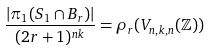<formula> <loc_0><loc_0><loc_500><loc_500>\frac { | \pi _ { 1 } ( S _ { 1 } \cap B _ { r } ) | } { ( 2 r + 1 ) ^ { n k } } = \rho _ { r } ( V _ { n , k , n } ( \mathbb { Z } ) )</formula> 